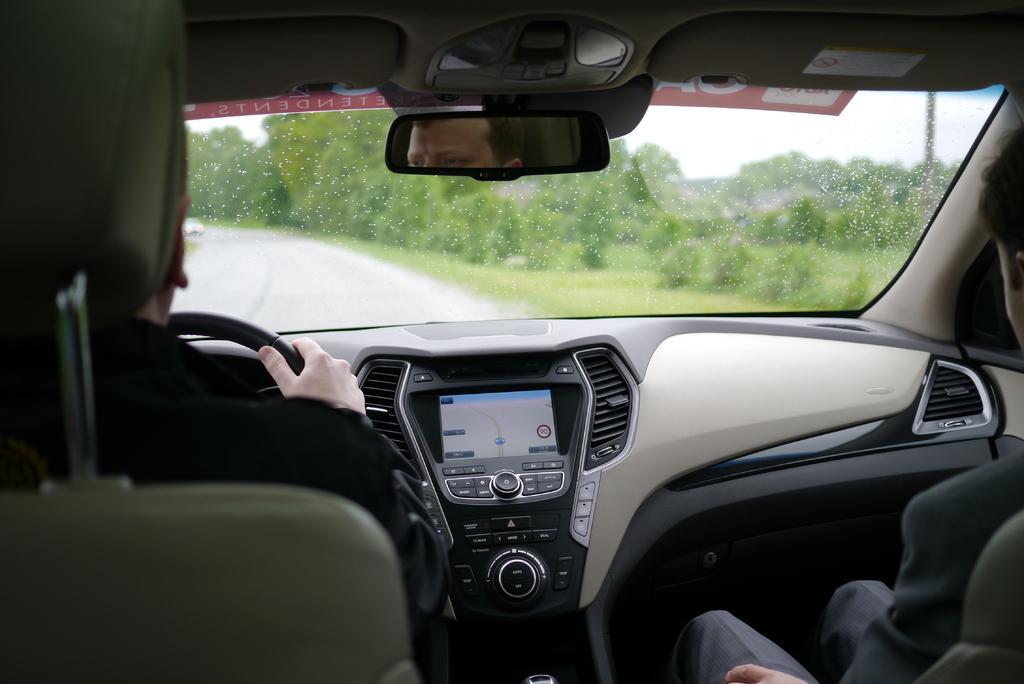Could you give a brief overview of what you see in this image? In this image we can see the inside view of the car that includes dashboard, two persons, windshield and in the background we can see trees and plants. 